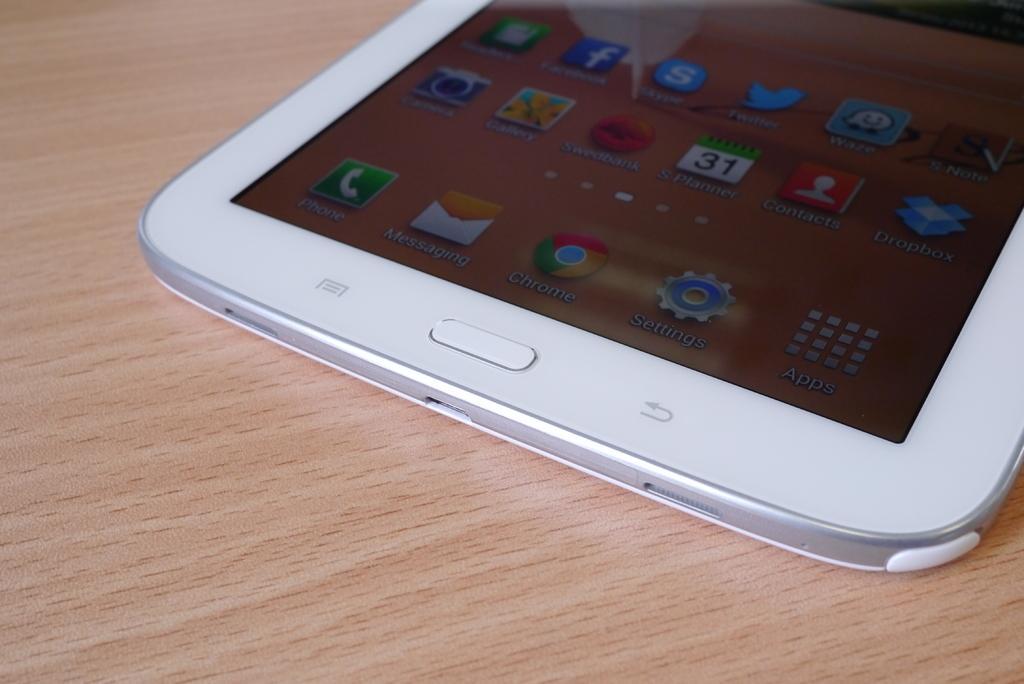Could you give a brief overview of what you see in this image? In this image I can see the white color mobile on the brown color surface. I can see some icons in the mobile. 